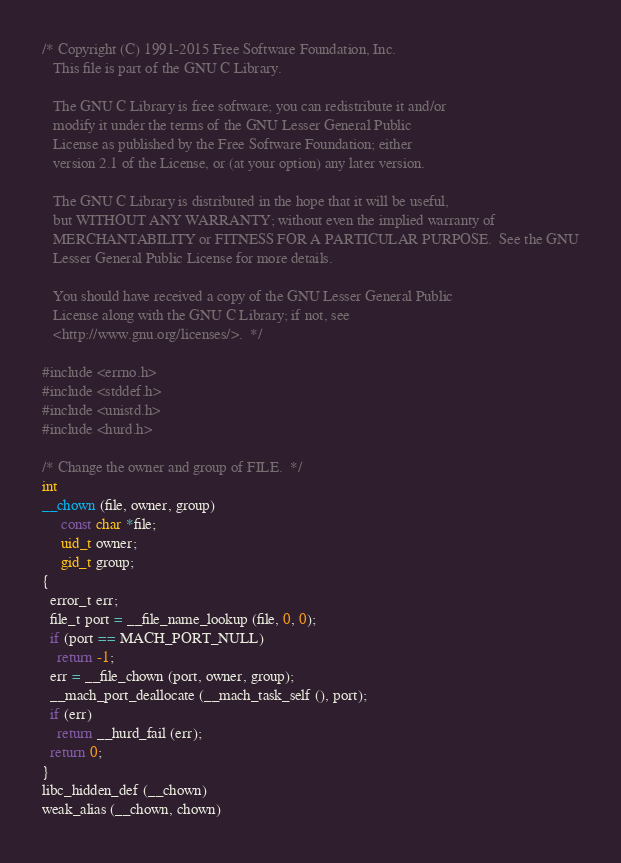<code> <loc_0><loc_0><loc_500><loc_500><_C_>/* Copyright (C) 1991-2015 Free Software Foundation, Inc.
   This file is part of the GNU C Library.

   The GNU C Library is free software; you can redistribute it and/or
   modify it under the terms of the GNU Lesser General Public
   License as published by the Free Software Foundation; either
   version 2.1 of the License, or (at your option) any later version.

   The GNU C Library is distributed in the hope that it will be useful,
   but WITHOUT ANY WARRANTY; without even the implied warranty of
   MERCHANTABILITY or FITNESS FOR A PARTICULAR PURPOSE.  See the GNU
   Lesser General Public License for more details.

   You should have received a copy of the GNU Lesser General Public
   License along with the GNU C Library; if not, see
   <http://www.gnu.org/licenses/>.  */

#include <errno.h>
#include <stddef.h>
#include <unistd.h>
#include <hurd.h>

/* Change the owner and group of FILE.  */
int
__chown (file, owner, group)
     const char *file;
     uid_t owner;
     gid_t group;
{
  error_t err;
  file_t port = __file_name_lookup (file, 0, 0);
  if (port == MACH_PORT_NULL)
    return -1;
  err = __file_chown (port, owner, group);
  __mach_port_deallocate (__mach_task_self (), port);
  if (err)
    return __hurd_fail (err);
  return 0;
}
libc_hidden_def (__chown)
weak_alias (__chown, chown)
</code> 